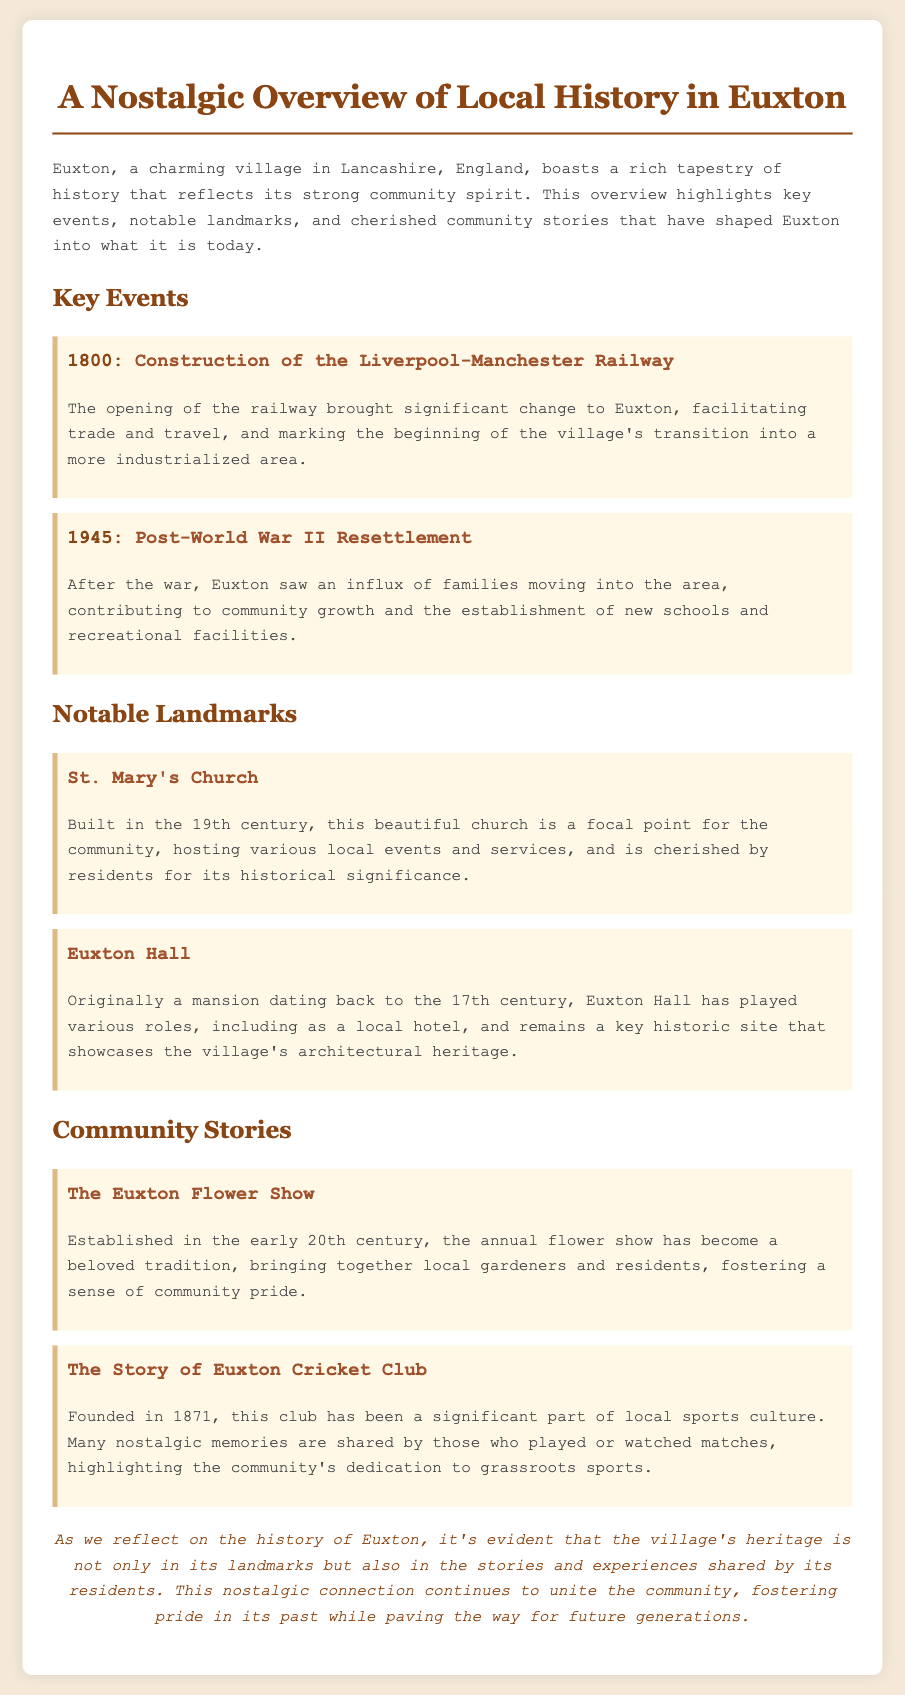what year was the Liverpool-Manchester Railway constructed? The document states that the construction took place in 1800.
Answer: 1800 what significant event occurred in 1945? The document mentions that there was a post-World War II resettlement in Euxton.
Answer: Post-World War II Resettlement what is the name of the church highlighted in the document? The document identifies St. Mary's Church as a notable landmark.
Answer: St. Mary's Church which historic site showcases the village's architectural heritage? According to the document, Euxton Hall is a key historic site highlighting the village's architectural heritage.
Answer: Euxton Hall how many years ago was the Euxton Cricket Club founded? The document states the club was founded in 1871; hence it was founded 152 years ago from 2023.
Answer: 152 years what tradition is associated with the Euxton Flower Show? It is indicated in the document that the flower show fosters a sense of community pride.
Answer: Sense of community pride what century was St. Mary's Church built in? The document specifies that St. Mary's Church was built in the 19th century.
Answer: 19th century what year did the annual flower show begin? The document states that the flower show was established in the early 20th century, which would be approximately around 1900.
Answer: Early 20th century 